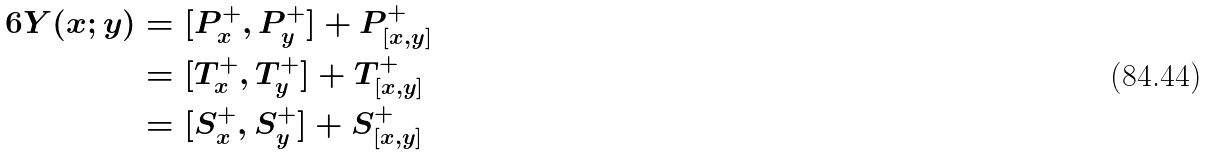<formula> <loc_0><loc_0><loc_500><loc_500>6 Y ( x ; y ) & = [ P ^ { + } _ { x } , P ^ { + } _ { y } ] + P ^ { + } _ { [ x , y ] } \\ & = [ T ^ { + } _ { x } , T ^ { + } _ { y } ] + T ^ { + } _ { [ x , y ] } \\ & = [ S ^ { + } _ { x } , S ^ { + } _ { y } ] + S ^ { + } _ { [ x , y ] }</formula> 